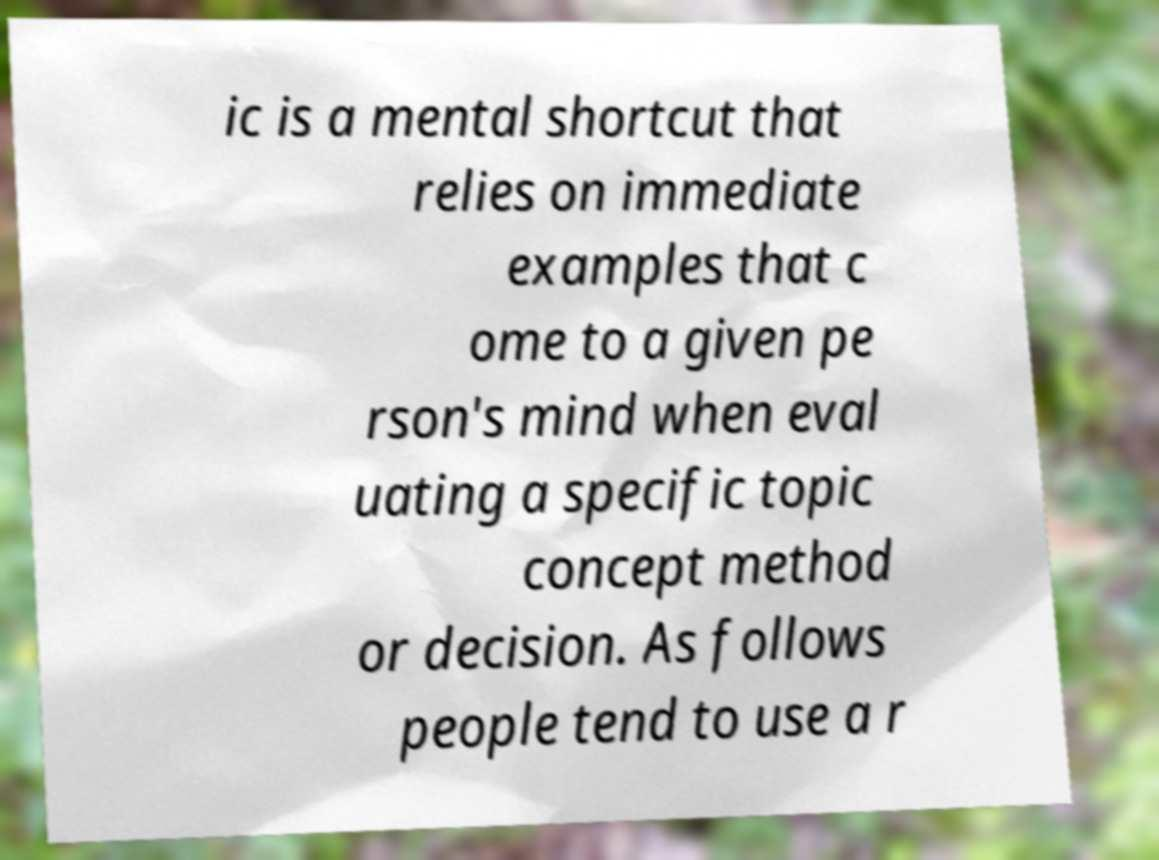Can you accurately transcribe the text from the provided image for me? ic is a mental shortcut that relies on immediate examples that c ome to a given pe rson's mind when eval uating a specific topic concept method or decision. As follows people tend to use a r 